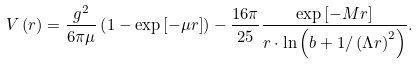Convert formula to latex. <formula><loc_0><loc_0><loc_500><loc_500>V \left ( r \right ) = \frac { g ^ { 2 } } { 6 \pi \mu } \left ( 1 - \exp \left [ - \mu r \right ] \right ) - \frac { 1 6 \pi } { 2 5 } \frac { \exp \left [ - M r \right ] } { r \cdot \ln \left ( b + 1 / \left ( \Lambda r \right ) ^ { 2 } \right ) } .</formula> 